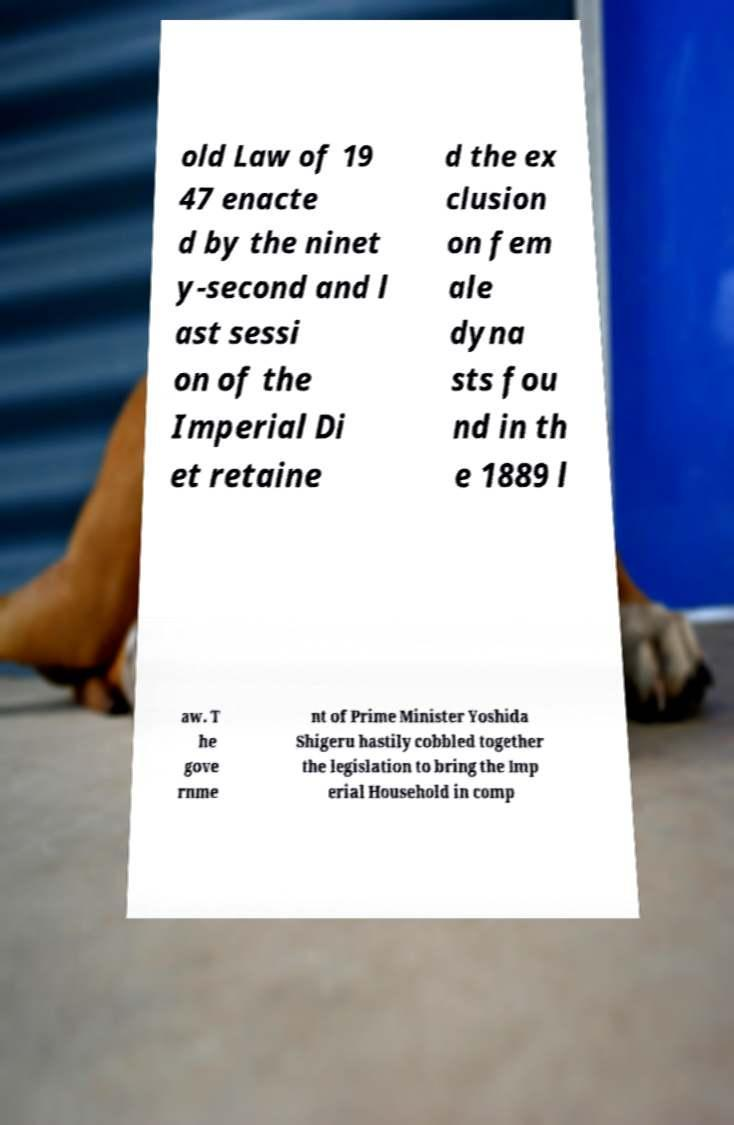Please read and relay the text visible in this image. What does it say? old Law of 19 47 enacte d by the ninet y-second and l ast sessi on of the Imperial Di et retaine d the ex clusion on fem ale dyna sts fou nd in th e 1889 l aw. T he gove rnme nt of Prime Minister Yoshida Shigeru hastily cobbled together the legislation to bring the Imp erial Household in comp 